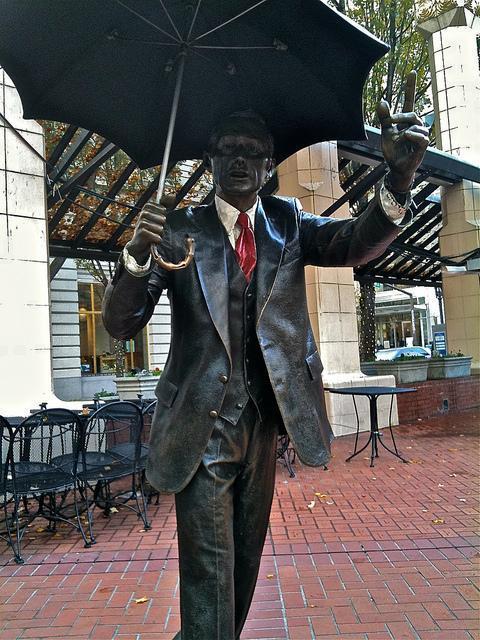How many dining tables can be seen?
Give a very brief answer. 1. How many chairs are there?
Give a very brief answer. 2. 